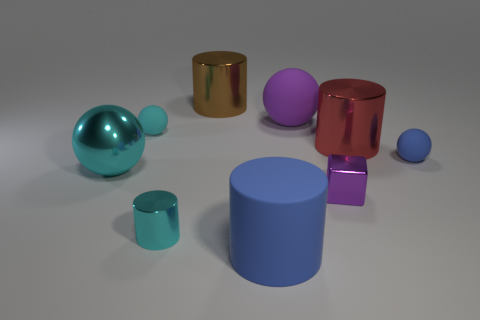Which shapes in the image are not spheres? In the image, there are several objects that are not spheres. These include two cylinders, one gold and one blue, and two cubes, one purple and one red. 